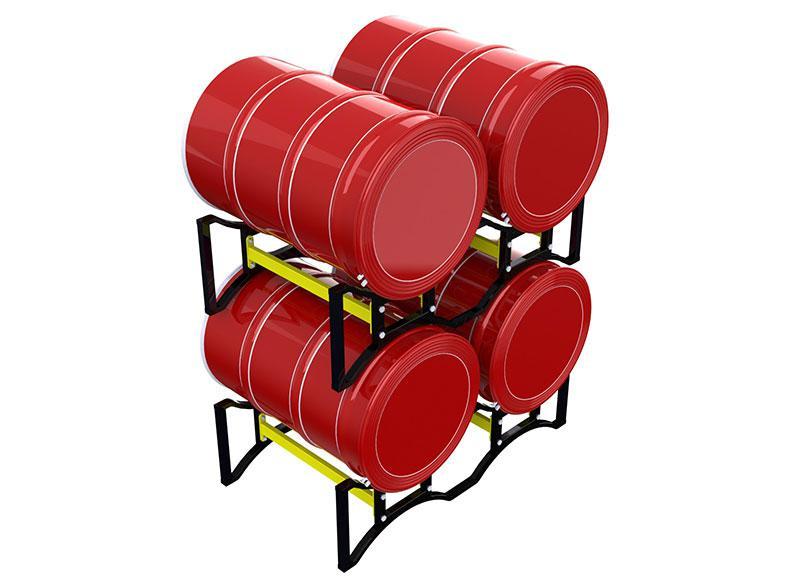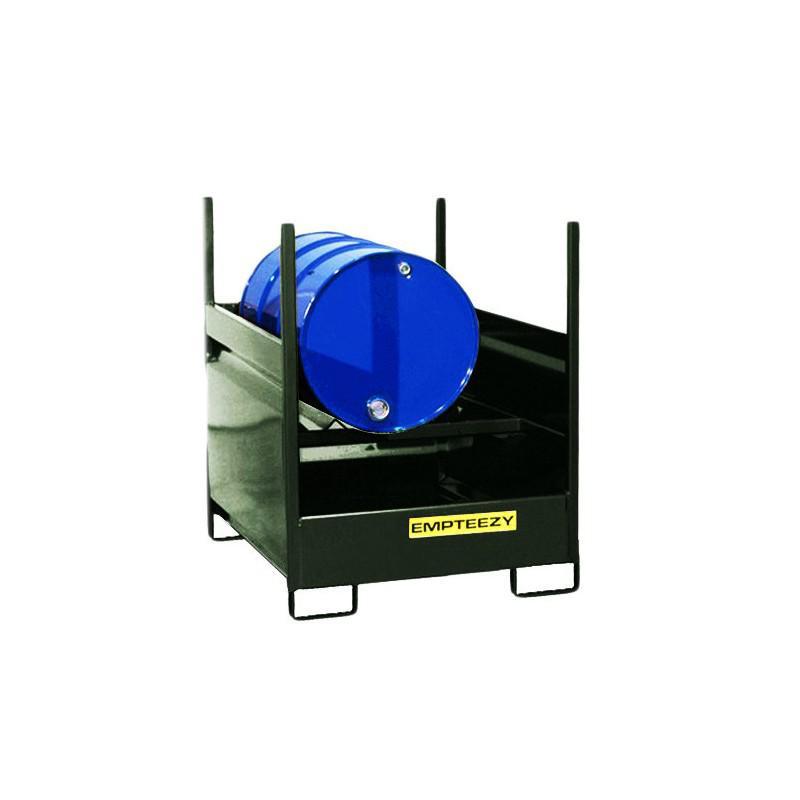The first image is the image on the left, the second image is the image on the right. For the images shown, is this caption "Red barrels sit in a black metal fenced container with chains on one side in one of the images." true? Answer yes or no. No. The first image is the image on the left, the second image is the image on the right. Analyze the images presented: Is the assertion "One image shows at least one cube-shaped black frame that contains four upright red barrels on a blue base." valid? Answer yes or no. No. 